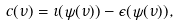Convert formula to latex. <formula><loc_0><loc_0><loc_500><loc_500>c ( \nu ) = \iota ( \psi ( \nu ) ) - \epsilon ( \psi ( \nu ) ) ,</formula> 